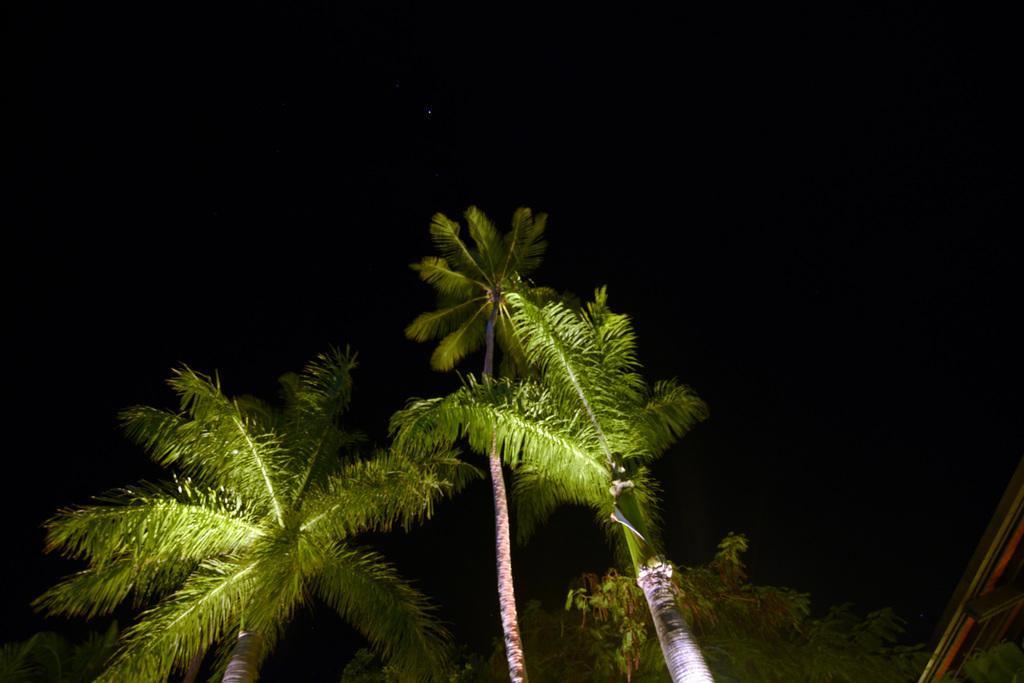What type of vegetation can be seen in the image? There are trees visible in the image. What celestial objects can be seen in the sky in the image? There are stars visible in the sky in the image. What type of comfort can be felt from the image? The image does not convey a sense of comfort; it simply depicts trees and stars in the sky. What scent is associated with the image? The image does not have a scent; it is a visual representation. 